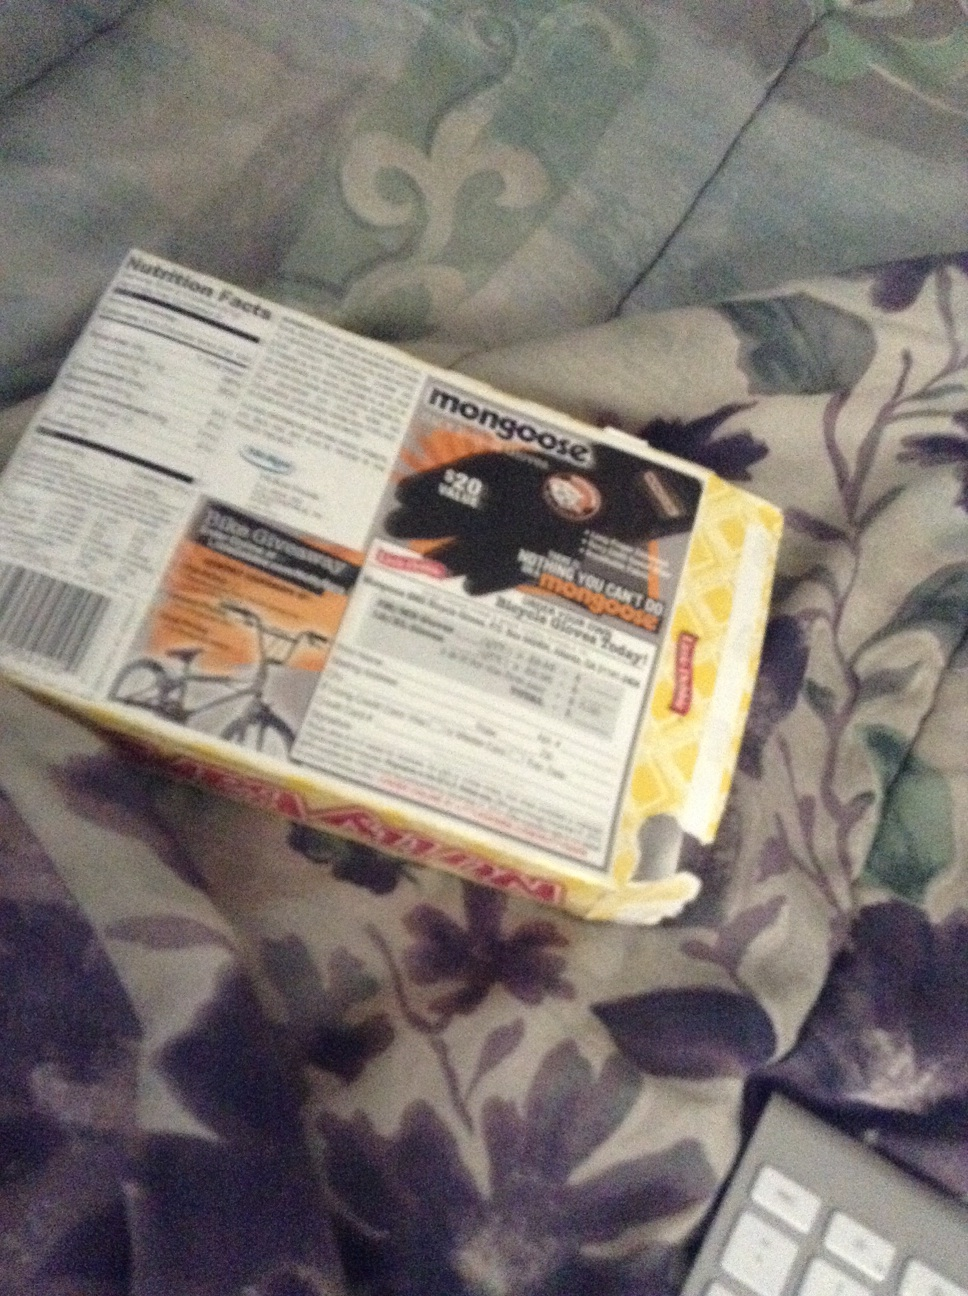What is this and can I type a question in noisy environments? This is a box containing Mongoose biking gloves, likely used for biking activities. The box also provides information on nutrition facts and usage details. In noisy environments, it is often possible to use speech-to-text features on many devices to type a question. Alternatively, typing using the keyboard remains a viable way to input questions despite background noise. 